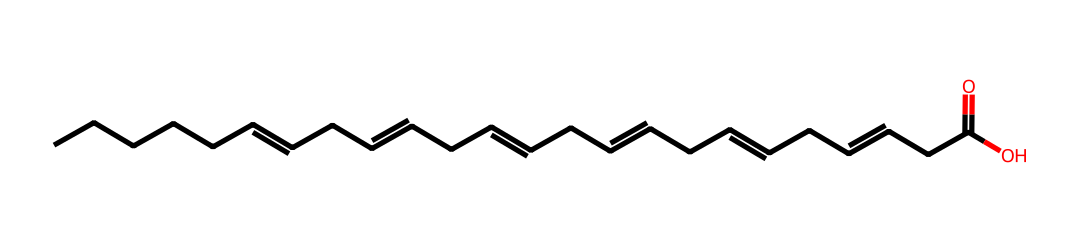What is the molecular formula of the displayed fatty acid? The SMILES representation can be analyzed to count the number of carbon (C), hydrogen (H), and oxygen (O) atoms. There are 18 carbon atoms, 34 hydrogen atoms, and 2 oxygen atoms. Thus, the molecular formula is C18H34O2.
Answer: C18H34O2 How many double bonds are present in this fatty acid? The SMILES notation indicates the presence of double bonds, which are represented by the '=' symbol. By counting the occurrences of '=' in the structure, we determine that there are 6 double bonds in total.
Answer: 6 What type of fatty acid is represented by this structure? The presence of multiple double bonds indicates that this is a polyunsaturated fatty acid. Since it contains omega-3 characteristics (with the first double bond at the third carbon from the methyl end), it qualifies as an omega-3 fatty acid.
Answer: polyunsaturated What does the 'CCC(=O)O' part of the SMILES signify? In the SMILES notation, 'CCC(=O)O' represents a carboxylic acid functional group (-COOH). The 'CCC' indicates a three-carbon chain leading to a carbonyl group (=O) and a hydroxyl group (-OH), which are characteristic of fatty acids.
Answer: carboxylic acid How many hydrogen atoms are attached to the carbon chain on average? To find the average number of hydrogen atoms attached to each carbon, we consider the total hydrogen count (34) and divide it by the total number of carbon atoms (18). This calculation gives us an average of about 1.89, but since hydrogen atoms are whole numbers, we can report that each carbon is typically bonded to 2 hydrogen atoms in an unsaturated fatty acid structure.
Answer: 2 